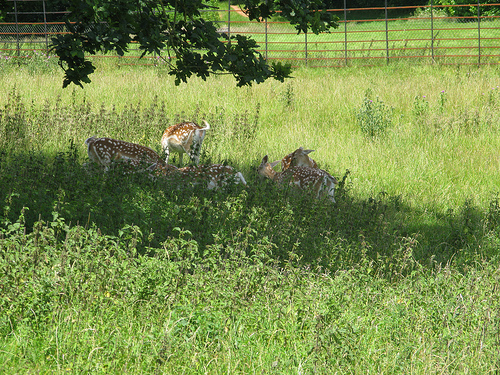<image>
Is there a deer on the grass? Yes. Looking at the image, I can see the deer is positioned on top of the grass, with the grass providing support. 